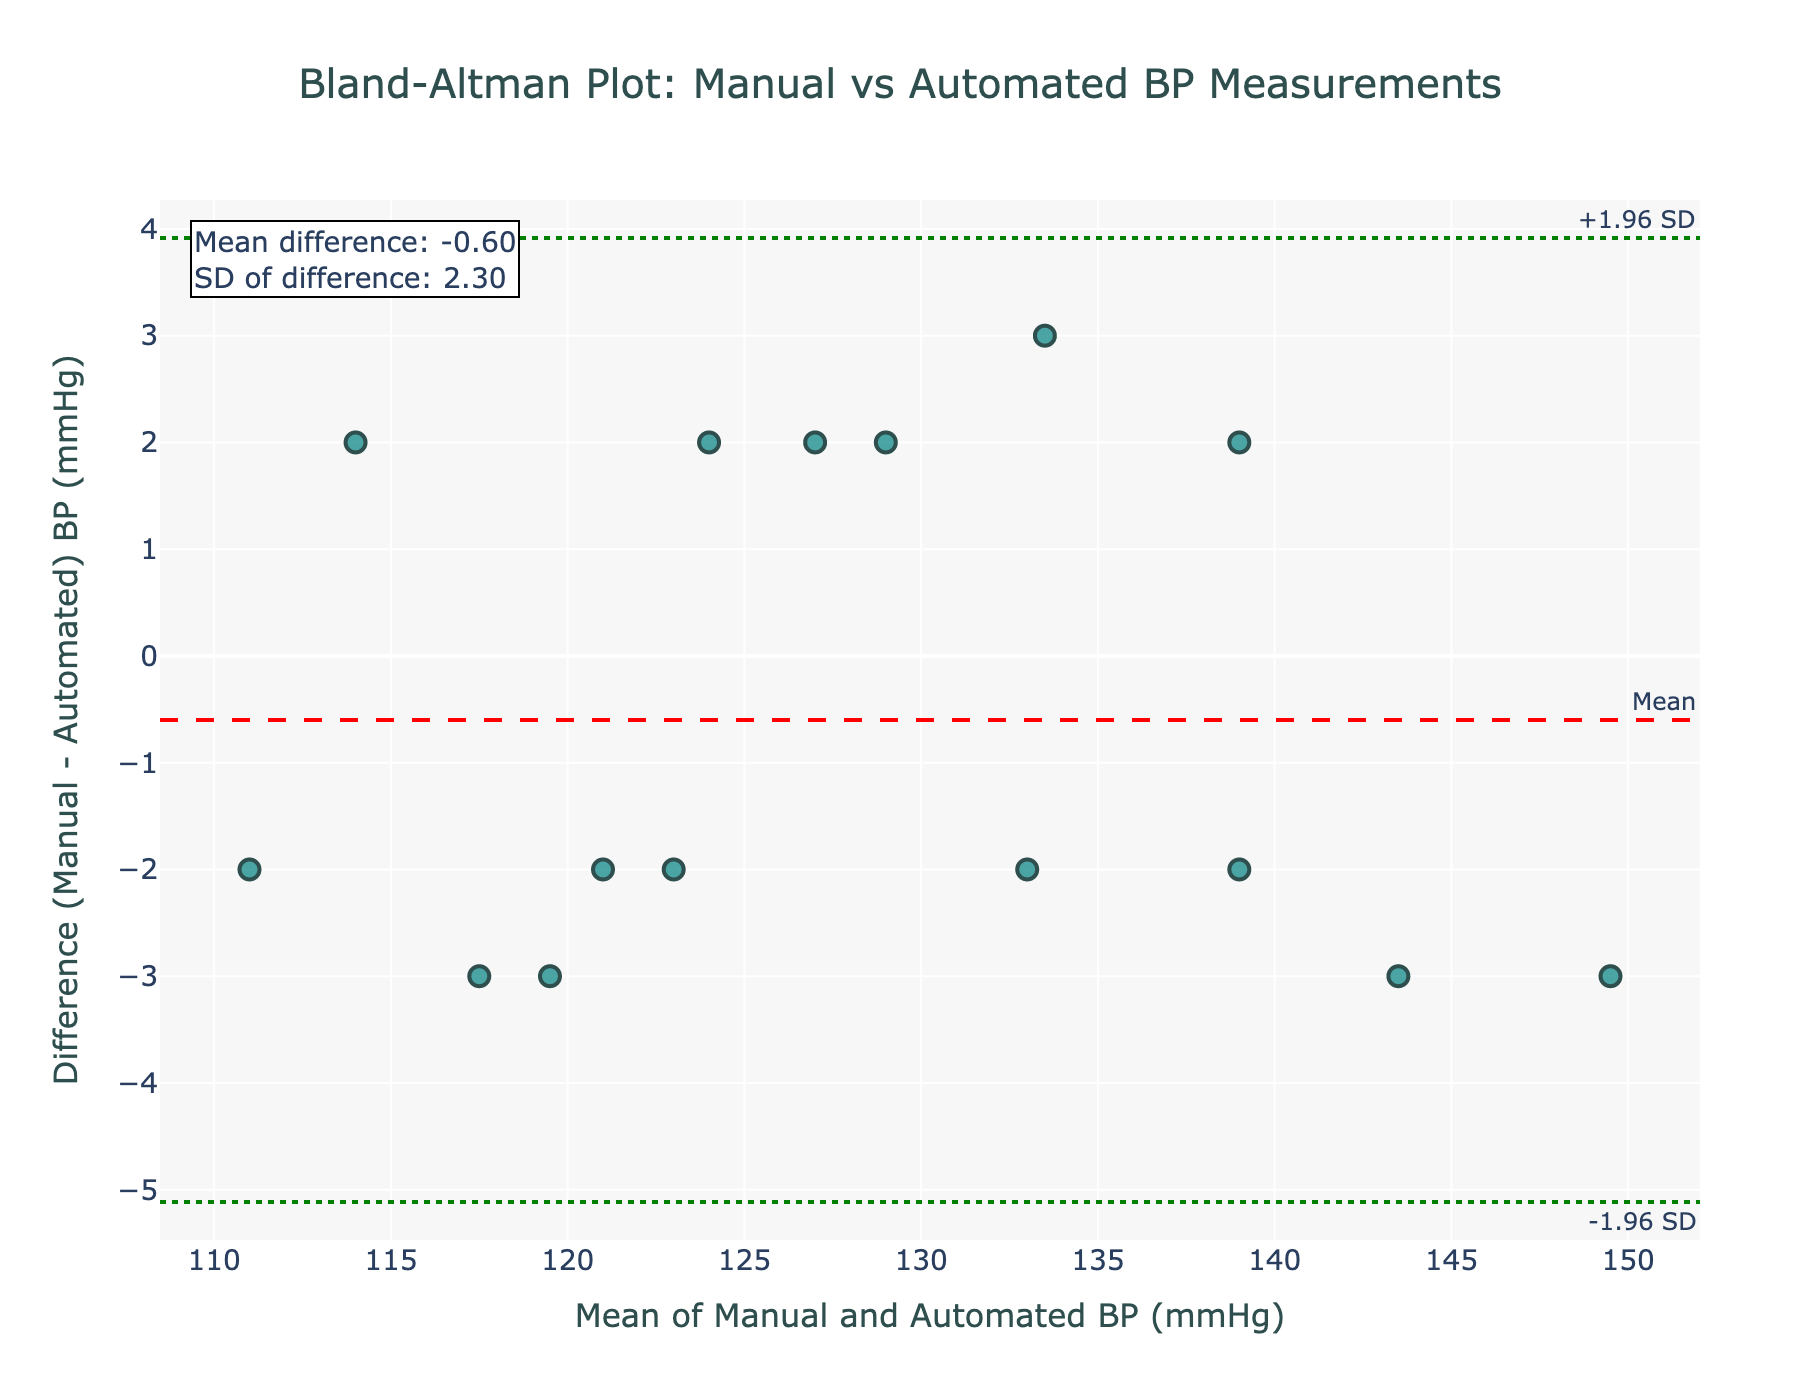What is the title of the plot? The title of the plot is displayed at the top and is centered. It provides information about what the plot represents.
Answer: Bland-Altman Plot: Manual vs Automated BP Measurements What do the x-axis and y-axis represent? The x-axis represents the mean of Manual and Automated BP (mmHg), while the y-axis represents the difference (Manual - Automated) BP (mmHg). This information is provided by the axis titles.
Answer: The x-axis is the mean of Manual and Automated BP (mmHg) and the y-axis is the difference (Manual - Automated) BP (mmHg) How are the limits of agreement represented in the plot? The limits of agreement are represented by horizontal dashed green lines at y = +1.96 SD (upper limit) and y = -1.96 SD (lower limit), as indicated by the annotations.
Answer: By dashed green lines at y = +1.96 SD and y = -1.96 SD What is the mean difference between Manual and Automated BP measurements? The mean difference is represented by a horizontal dashed red line and the specific value is also annotated near the line.
Answer: 0.53 mmHg How many data points are there in the plot? Each data point is represented by a marker on the plot. Counting the number of markers gives the total number of data points.
Answer: 15 Which data point shows the maximum difference between Manual and Automated BP measurements? To find this, identify the point with the largest distance from the y = 0 axis. This is at the y-value 3, corresponding to Patient_ID P011.
Answer: Patient_ID P011 Are the differences between the Manual and Automated BP readings mostly within the limits of agreement? By observing the plot, most data points fall within the area defined by the upper and lower green lines, indicating the limits of agreement.
Answer: Yes Which patient had the smallest mean BP value? To determine this, identify the data point with the smallest x-value, representing the mean of Manual and Automated BP. The smallest mean value corresponds to Patient_ID P006.
Answer: Patient_ID P006 Is there a noticeable trend between the mean BP value and the difference between Manual and Automated BP readings? A trend would be indicated by a pattern or correlation in the scatter of points. In this plot, the points seem to be randomly dispersed around the mean difference line, suggesting no noticeable trend.
Answer: No What is the range of the differences shown in the plot? The range is determined by the difference between the maximum and minimum values on the y-axis. The highest point is 3 and the lowest point is -3, so the range is 3 - (-3) = 6 mmHg.
Answer: 6 mmHg 